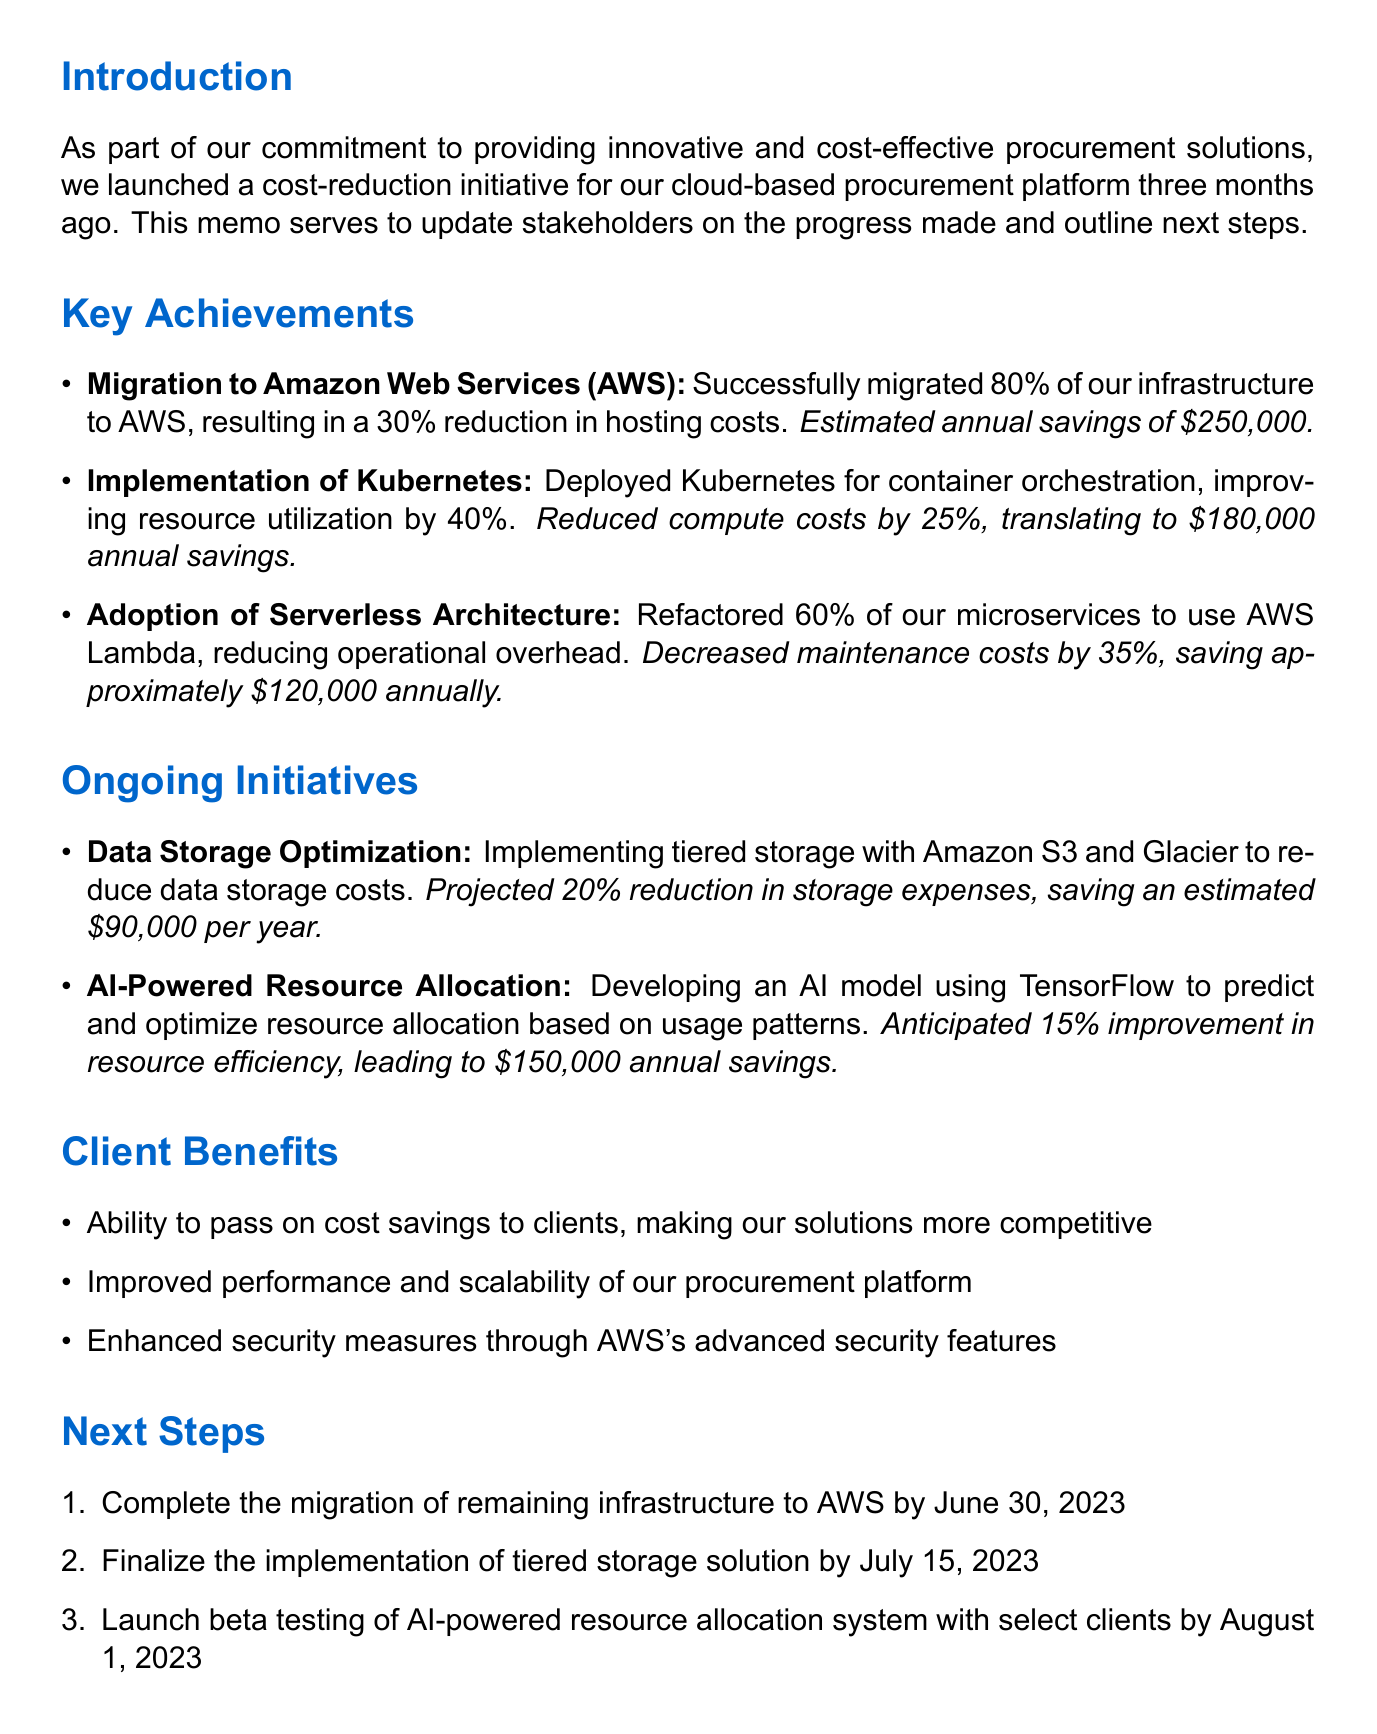What is the date of the memo? The date of the memo can be found in the header section of the document.
Answer: May 15, 2023 How much has been saved through migration to AWS? The estimated savings from the migration to AWS are mentioned under key achievements.
Answer: $250,000 What percentage of the infrastructure is migrated to AWS? The document specifies the percentage of infrastructure migration in the key achievements section.
Answer: 80% What is the expected impact of the AI-Powered Resource Allocation initiative? The expected impact of this initiative is listed in the ongoing initiatives section of the memo.
Answer: $150,000 annual savings By when will the migration of remaining infrastructure to AWS be completed? The timeline for completing the migration is outlined in the next steps section.
Answer: June 30, 2023 What is the total projected annual savings from the cost-reduction initiative? This figure is summarized in the conclusion section of the memo.
Answer: $790,000 What technology is used in the implementation of Kubernetes? The document provides details on the technology used in the implementation within the key achievements.
Answer: Kubernetes What benefit does adopting serverless architecture provide? The benefits of adopting serverless architecture are outlined in the key achievements section.
Answer: Decreased maintenance costs by 35% What storage solution is being implemented for data storage optimization? The type of storage solution being implemented is described in the ongoing initiatives section.
Answer: Amazon S3 and Glacier 